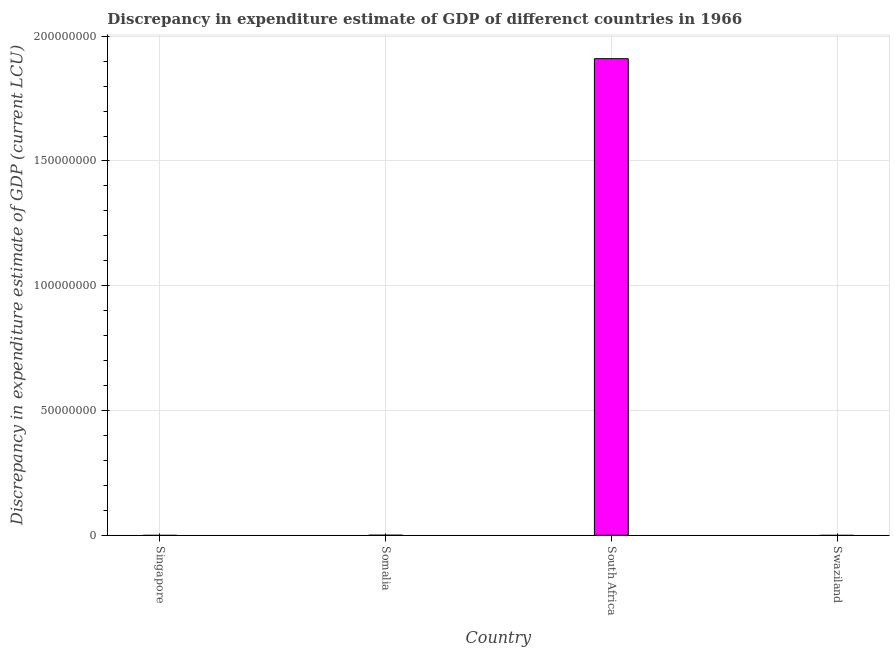Does the graph contain grids?
Your answer should be compact. Yes. What is the title of the graph?
Provide a short and direct response. Discrepancy in expenditure estimate of GDP of differenct countries in 1966. What is the label or title of the X-axis?
Offer a terse response. Country. What is the label or title of the Y-axis?
Make the answer very short. Discrepancy in expenditure estimate of GDP (current LCU). Across all countries, what is the maximum discrepancy in expenditure estimate of gdp?
Offer a very short reply. 1.91e+08. In which country was the discrepancy in expenditure estimate of gdp maximum?
Give a very brief answer. South Africa. What is the sum of the discrepancy in expenditure estimate of gdp?
Your response must be concise. 1.91e+08. What is the average discrepancy in expenditure estimate of gdp per country?
Offer a terse response. 4.78e+07. In how many countries, is the discrepancy in expenditure estimate of gdp greater than 60000000 LCU?
Your answer should be very brief. 1. What is the difference between the highest and the lowest discrepancy in expenditure estimate of gdp?
Keep it short and to the point. 1.91e+08. In how many countries, is the discrepancy in expenditure estimate of gdp greater than the average discrepancy in expenditure estimate of gdp taken over all countries?
Offer a very short reply. 1. What is the Discrepancy in expenditure estimate of GDP (current LCU) in Somalia?
Provide a short and direct response. 0. What is the Discrepancy in expenditure estimate of GDP (current LCU) in South Africa?
Make the answer very short. 1.91e+08. 